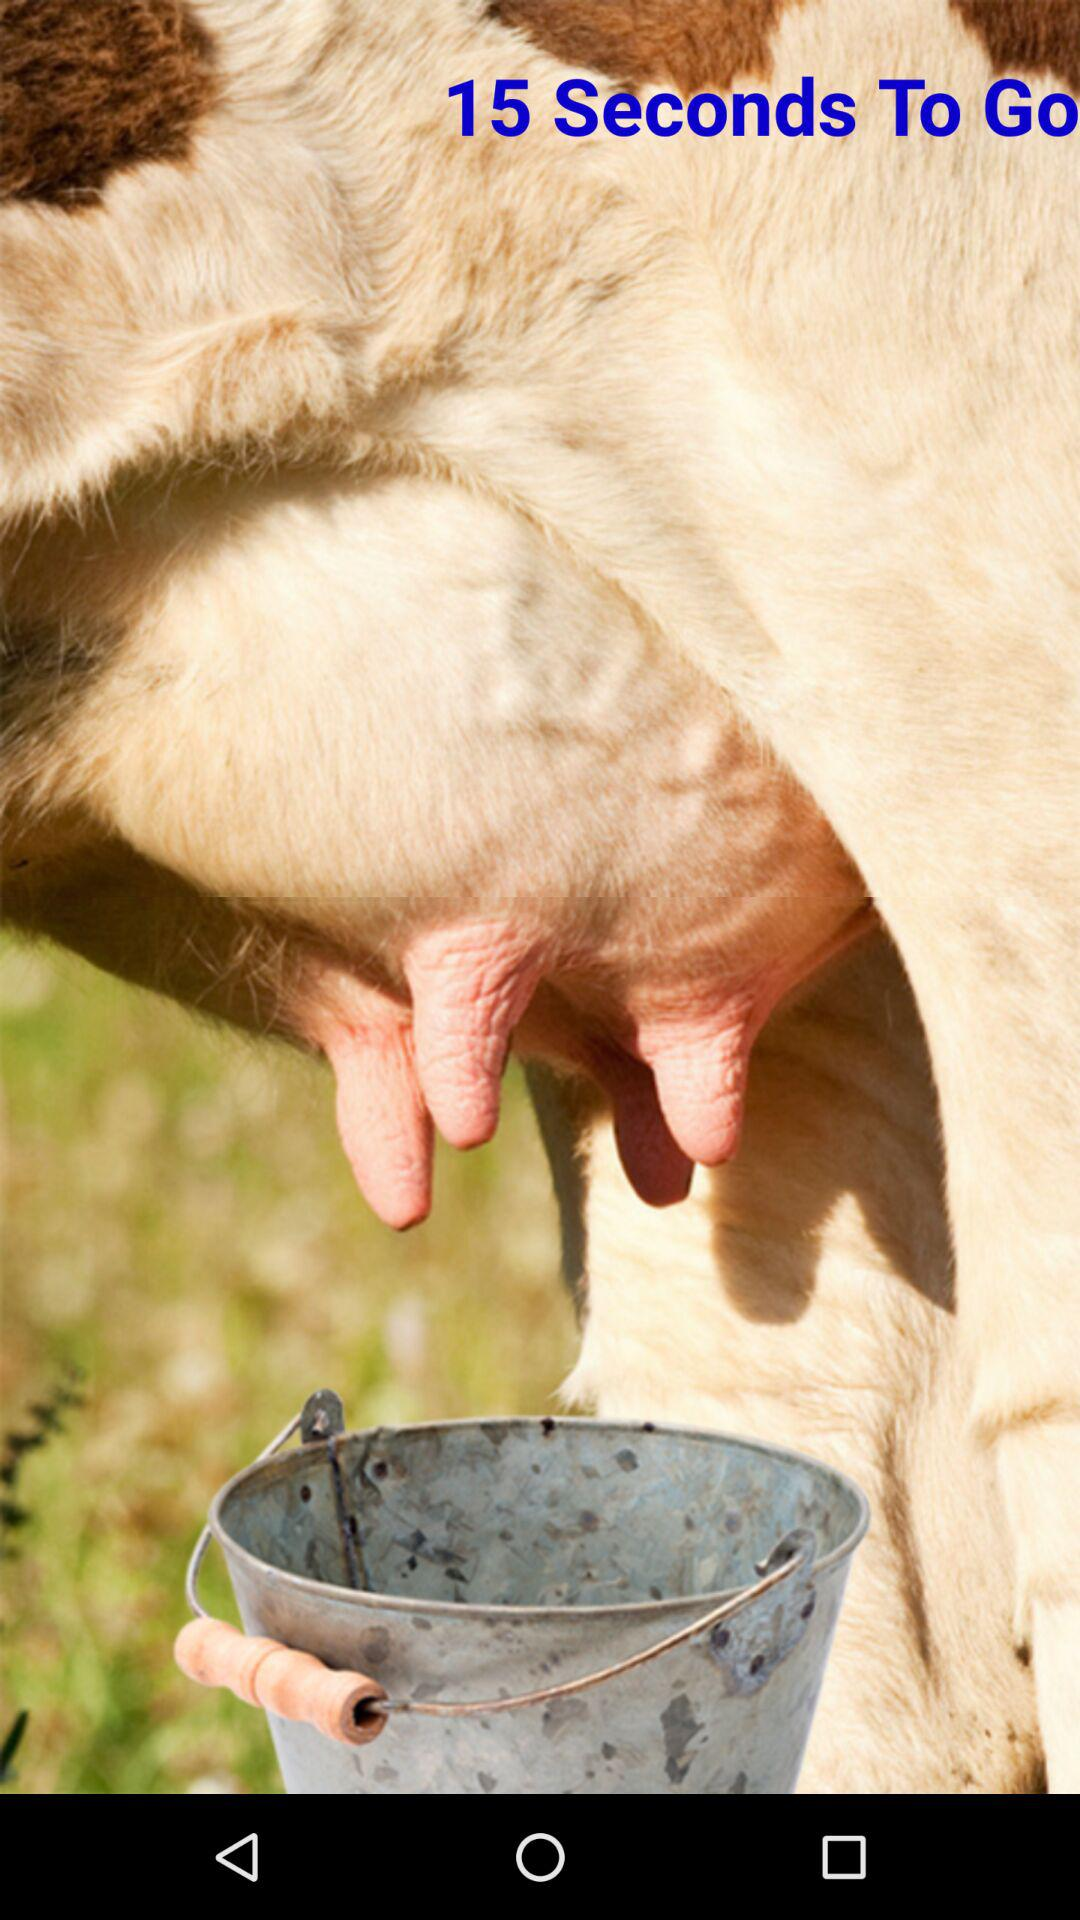How many more seconds are there until the timer is up?
Answer the question using a single word or phrase. 15 